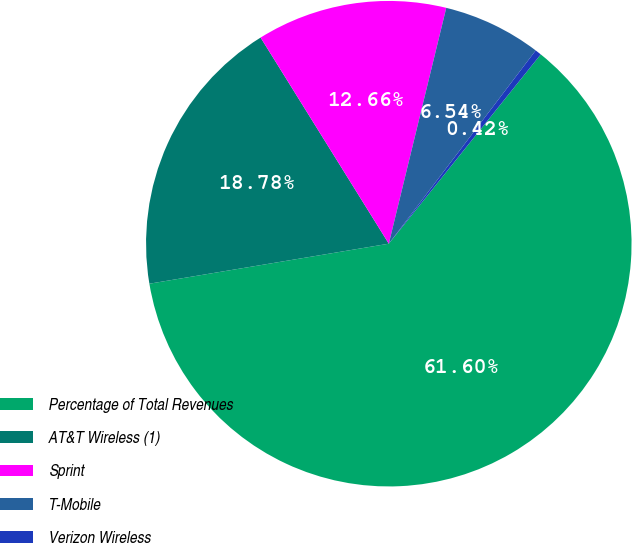Convert chart to OTSL. <chart><loc_0><loc_0><loc_500><loc_500><pie_chart><fcel>Percentage of Total Revenues<fcel>AT&T Wireless (1)<fcel>Sprint<fcel>T-Mobile<fcel>Verizon Wireless<nl><fcel>61.6%<fcel>18.78%<fcel>12.66%<fcel>6.54%<fcel>0.42%<nl></chart> 